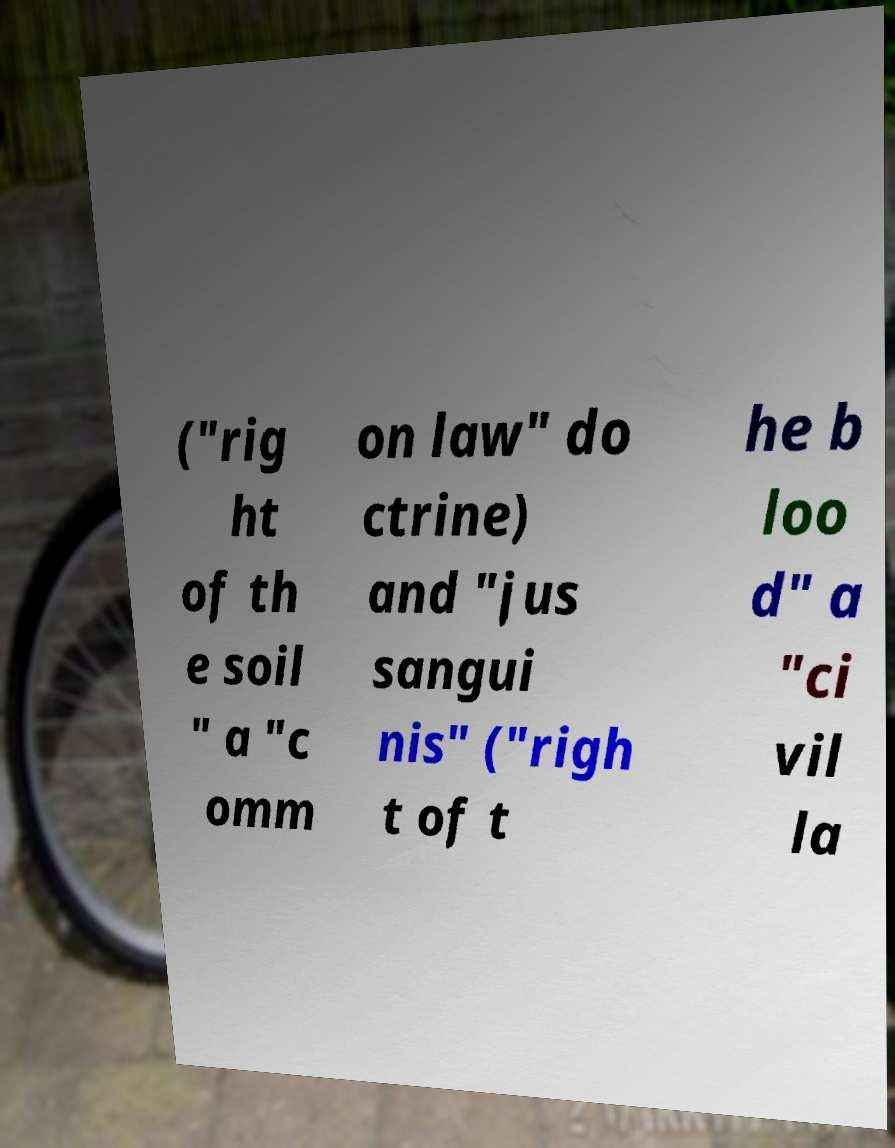For documentation purposes, I need the text within this image transcribed. Could you provide that? ("rig ht of th e soil " a "c omm on law" do ctrine) and "jus sangui nis" ("righ t of t he b loo d" a "ci vil la 